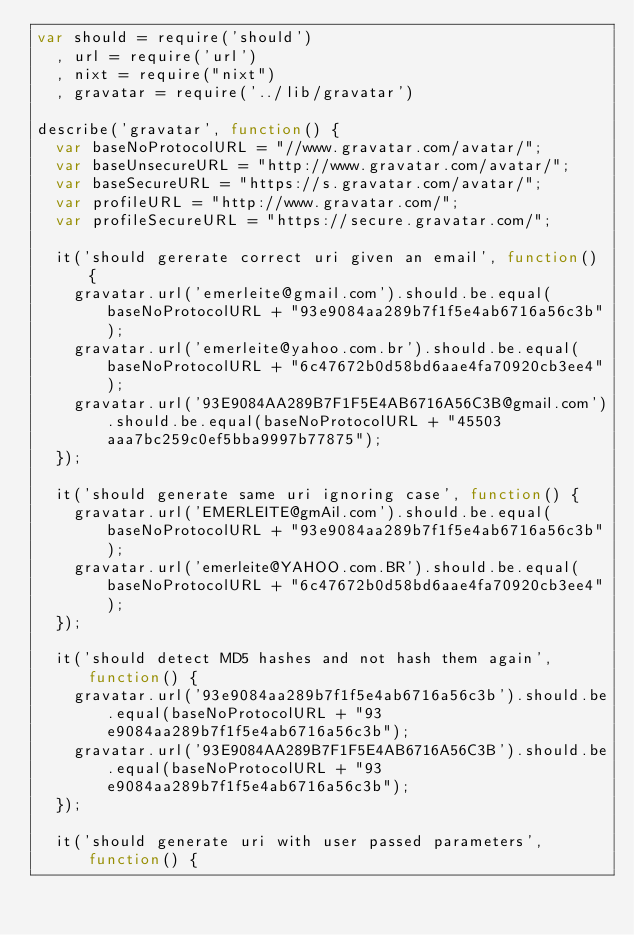Convert code to text. <code><loc_0><loc_0><loc_500><loc_500><_JavaScript_>var should = require('should')
  , url = require('url')
  , nixt = require("nixt")
  , gravatar = require('../lib/gravatar')

describe('gravatar', function() {
  var baseNoProtocolURL = "//www.gravatar.com/avatar/";
  var baseUnsecureURL = "http://www.gravatar.com/avatar/";
  var baseSecureURL = "https://s.gravatar.com/avatar/";
  var profileURL = "http://www.gravatar.com/";
  var profileSecureURL = "https://secure.gravatar.com/";

  it('should gererate correct uri given an email', function() {
    gravatar.url('emerleite@gmail.com').should.be.equal(baseNoProtocolURL + "93e9084aa289b7f1f5e4ab6716a56c3b");
    gravatar.url('emerleite@yahoo.com.br').should.be.equal(baseNoProtocolURL + "6c47672b0d58bd6aae4fa70920cb3ee4");
    gravatar.url('93E9084AA289B7F1F5E4AB6716A56C3B@gmail.com').should.be.equal(baseNoProtocolURL + "45503aaa7bc259c0ef5bba9997b77875");
  });

  it('should generate same uri ignoring case', function() {
    gravatar.url('EMERLEITE@gmAil.com').should.be.equal(baseNoProtocolURL + "93e9084aa289b7f1f5e4ab6716a56c3b");
    gravatar.url('emerleite@YAHOO.com.BR').should.be.equal(baseNoProtocolURL + "6c47672b0d58bd6aae4fa70920cb3ee4");
  });

  it('should detect MD5 hashes and not hash them again', function() {
    gravatar.url('93e9084aa289b7f1f5e4ab6716a56c3b').should.be.equal(baseNoProtocolURL + "93e9084aa289b7f1f5e4ab6716a56c3b");
    gravatar.url('93E9084AA289B7F1F5E4AB6716A56C3B').should.be.equal(baseNoProtocolURL + "93e9084aa289b7f1f5e4ab6716a56c3b");
  });

  it('should generate uri with user passed parameters', function() {</code> 